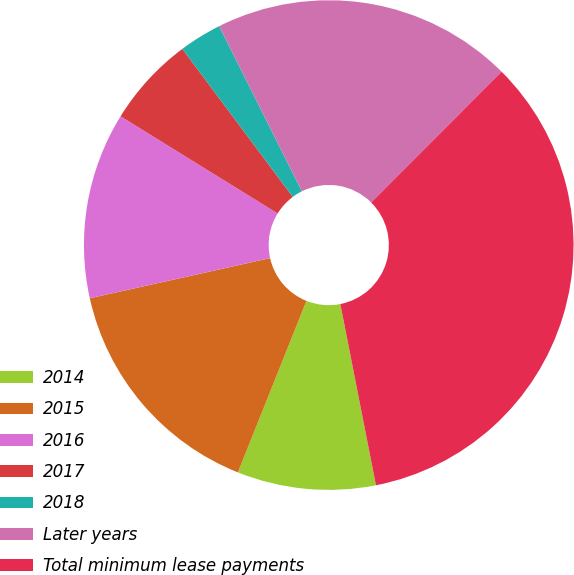Convert chart to OTSL. <chart><loc_0><loc_0><loc_500><loc_500><pie_chart><fcel>2014<fcel>2015<fcel>2016<fcel>2017<fcel>2018<fcel>Later years<fcel>Total minimum lease payments<nl><fcel>9.14%<fcel>15.46%<fcel>12.3%<fcel>5.98%<fcel>2.82%<fcel>19.86%<fcel>34.43%<nl></chart> 